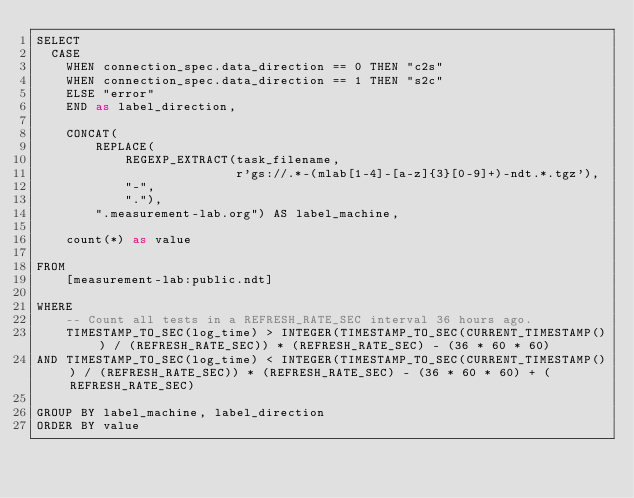Convert code to text. <code><loc_0><loc_0><loc_500><loc_500><_SQL_>SELECT
  CASE 
    WHEN connection_spec.data_direction == 0 THEN "c2s"
    WHEN connection_spec.data_direction == 1 THEN "s2c"
    ELSE "error"
    END as label_direction,

    CONCAT(
        REPLACE(
            REGEXP_EXTRACT(task_filename,
                           r'gs://.*-(mlab[1-4]-[a-z]{3}[0-9]+)-ndt.*.tgz'),
            "-",
            "."),
        ".measurement-lab.org") AS label_machine,

    count(*) as value

FROM
    [measurement-lab:public.ndt]

WHERE
    -- Count all tests in a REFRESH_RATE_SEC interval 36 hours ago.
    TIMESTAMP_TO_SEC(log_time) > INTEGER(TIMESTAMP_TO_SEC(CURRENT_TIMESTAMP()) / (REFRESH_RATE_SEC)) * (REFRESH_RATE_SEC) - (36 * 60 * 60)
AND TIMESTAMP_TO_SEC(log_time) < INTEGER(TIMESTAMP_TO_SEC(CURRENT_TIMESTAMP()) / (REFRESH_RATE_SEC)) * (REFRESH_RATE_SEC) - (36 * 60 * 60) + (REFRESH_RATE_SEC)

GROUP BY label_machine, label_direction
ORDER BY value
</code> 